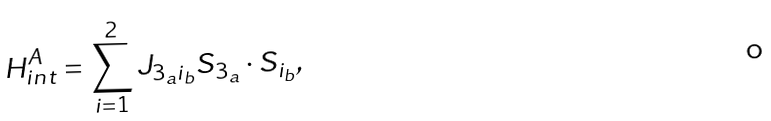Convert formula to latex. <formula><loc_0><loc_0><loc_500><loc_500>H ^ { A } _ { i n t } = \sum _ { i = 1 } ^ { 2 } J _ { 3 _ { a } i _ { b } } S _ { 3 _ { a } } \cdot S _ { i _ { b } } ,</formula> 